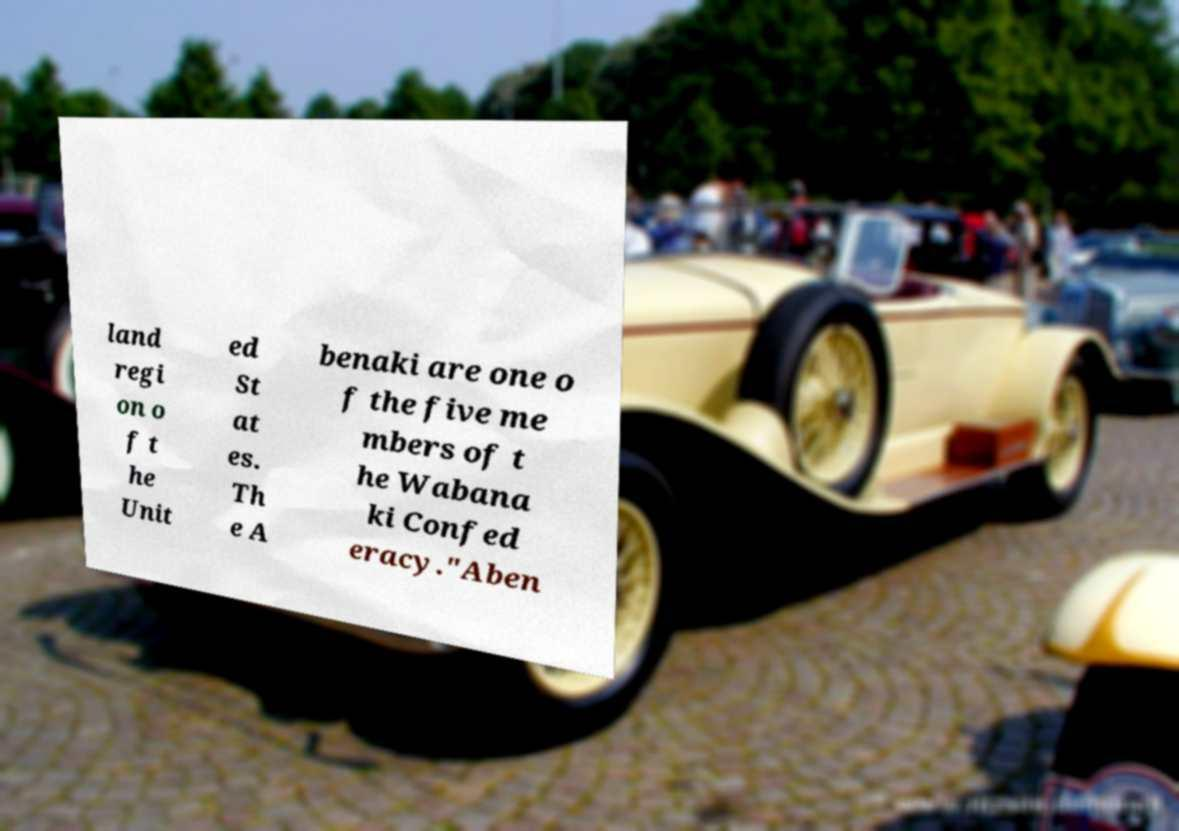For documentation purposes, I need the text within this image transcribed. Could you provide that? land regi on o f t he Unit ed St at es. Th e A benaki are one o f the five me mbers of t he Wabana ki Confed eracy."Aben 